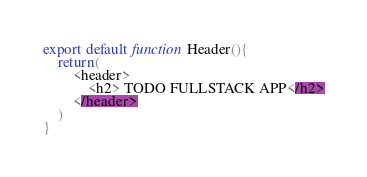Convert code to text. <code><loc_0><loc_0><loc_500><loc_500><_JavaScript_>export default function Header(){
    return(
        <header>
            <h2> TODO FULLSTACK APP</h2>
        </header>
    )
}</code> 